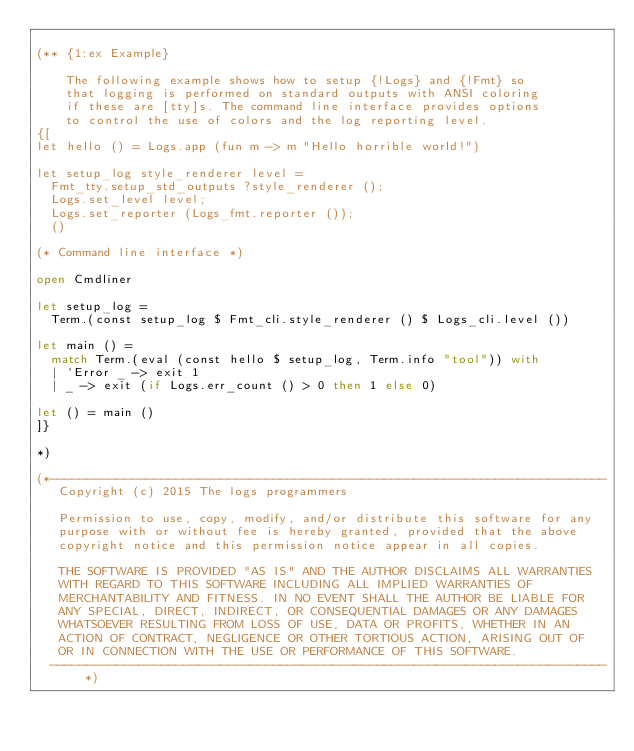<code> <loc_0><loc_0><loc_500><loc_500><_OCaml_>
(** {1:ex Example}

    The following example shows how to setup {!Logs} and {!Fmt} so
    that logging is performed on standard outputs with ANSI coloring
    if these are [tty]s. The command line interface provides options
    to control the use of colors and the log reporting level.
{[
let hello () = Logs.app (fun m -> m "Hello horrible world!")

let setup_log style_renderer level =
  Fmt_tty.setup_std_outputs ?style_renderer ();
  Logs.set_level level;
  Logs.set_reporter (Logs_fmt.reporter ());
  ()

(* Command line interface *)

open Cmdliner

let setup_log =
  Term.(const setup_log $ Fmt_cli.style_renderer () $ Logs_cli.level ())

let main () =
  match Term.(eval (const hello $ setup_log, Term.info "tool")) with
  | `Error _ -> exit 1
  | _ -> exit (if Logs.err_count () > 0 then 1 else 0)

let () = main ()
]}

*)

(*---------------------------------------------------------------------------
   Copyright (c) 2015 The logs programmers

   Permission to use, copy, modify, and/or distribute this software for any
   purpose with or without fee is hereby granted, provided that the above
   copyright notice and this permission notice appear in all copies.

   THE SOFTWARE IS PROVIDED "AS IS" AND THE AUTHOR DISCLAIMS ALL WARRANTIES
   WITH REGARD TO THIS SOFTWARE INCLUDING ALL IMPLIED WARRANTIES OF
   MERCHANTABILITY AND FITNESS. IN NO EVENT SHALL THE AUTHOR BE LIABLE FOR
   ANY SPECIAL, DIRECT, INDIRECT, OR CONSEQUENTIAL DAMAGES OR ANY DAMAGES
   WHATSOEVER RESULTING FROM LOSS OF USE, DATA OR PROFITS, WHETHER IN AN
   ACTION OF CONTRACT, NEGLIGENCE OR OTHER TORTIOUS ACTION, ARISING OUT OF
   OR IN CONNECTION WITH THE USE OR PERFORMANCE OF THIS SOFTWARE.
  ---------------------------------------------------------------------------*)
</code> 